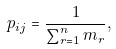Convert formula to latex. <formula><loc_0><loc_0><loc_500><loc_500>p _ { i j } = \frac { 1 } { \sum _ { r = 1 } ^ { n } m _ { r } } ,</formula> 